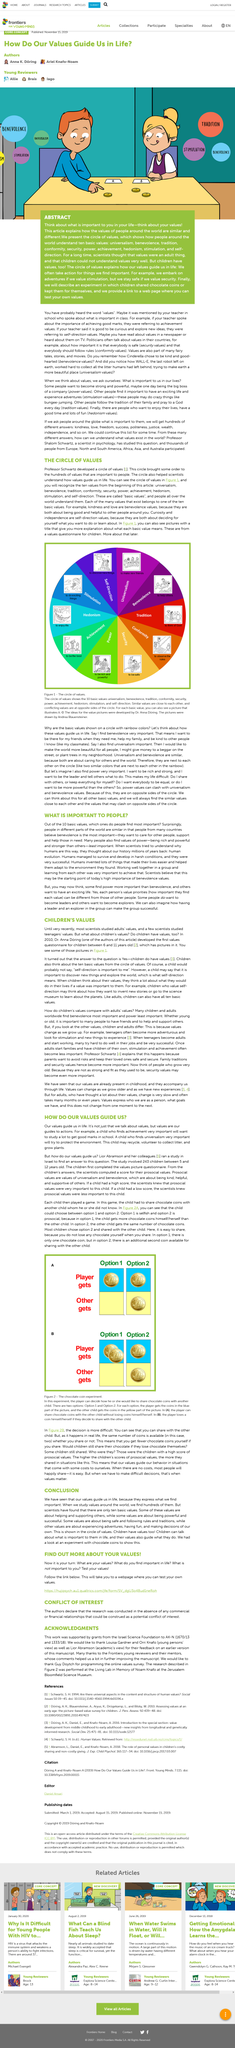Draw attention to some important aspects in this diagram. Professor Schwartz developed the circle of values. In the study conducted by Abramson, a high score indicates that prosocial values are important to the child. It is important for children to develop an interest in protecting the environment because certain values, such as universalism, may contribute to this interest. It is a fact that children possess all ten basic values. The circle of values is a circular model that organizes and prioritizes the many values that are significant to individuals, bringing order and clarity to a complex landscape of values. 